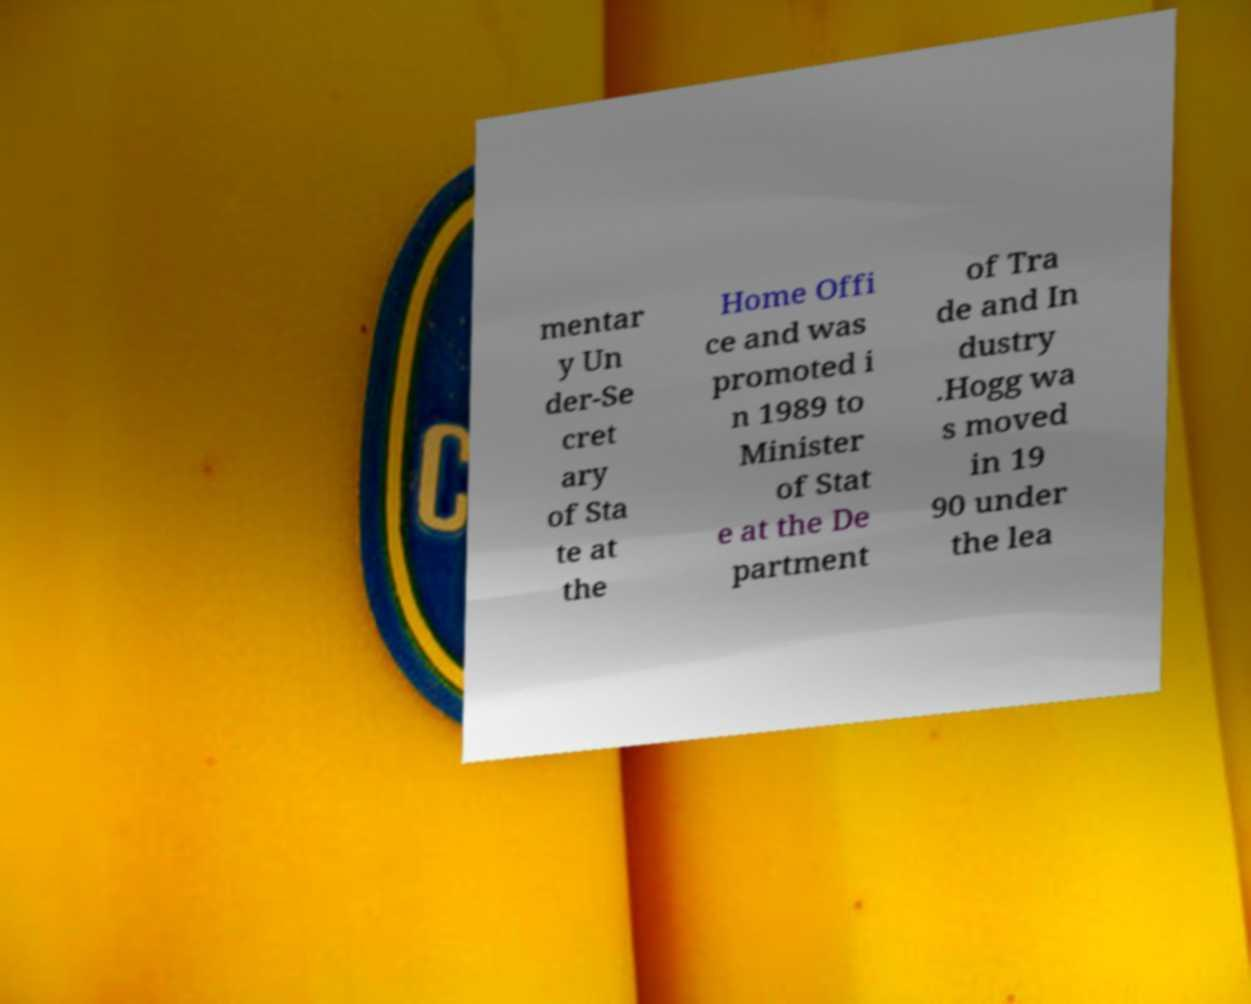What messages or text are displayed in this image? I need them in a readable, typed format. mentar y Un der-Se cret ary of Sta te at the Home Offi ce and was promoted i n 1989 to Minister of Stat e at the De partment of Tra de and In dustry .Hogg wa s moved in 19 90 under the lea 